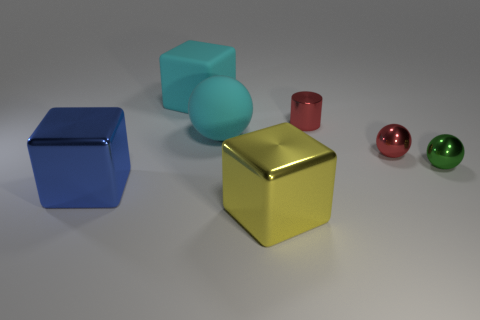Add 1 gray balls. How many objects exist? 8 Subtract all cubes. How many objects are left? 4 Subtract all small cylinders. Subtract all large red matte cylinders. How many objects are left? 6 Add 5 cyan spheres. How many cyan spheres are left? 6 Add 5 large green objects. How many large green objects exist? 5 Subtract 0 yellow cylinders. How many objects are left? 7 